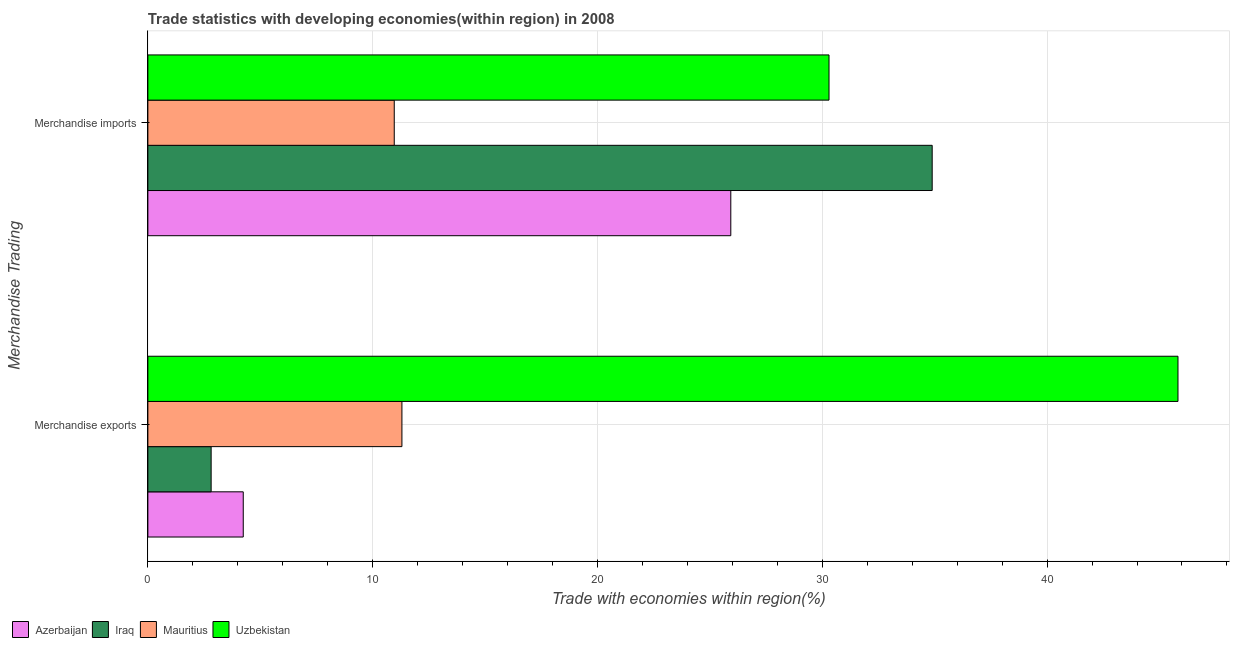How many groups of bars are there?
Give a very brief answer. 2. Are the number of bars on each tick of the Y-axis equal?
Offer a very short reply. Yes. How many bars are there on the 1st tick from the top?
Ensure brevity in your answer.  4. How many bars are there on the 2nd tick from the bottom?
Ensure brevity in your answer.  4. What is the label of the 2nd group of bars from the top?
Give a very brief answer. Merchandise exports. What is the merchandise imports in Mauritius?
Your answer should be very brief. 10.96. Across all countries, what is the maximum merchandise imports?
Your answer should be compact. 34.89. Across all countries, what is the minimum merchandise imports?
Your answer should be very brief. 10.96. In which country was the merchandise exports maximum?
Your answer should be very brief. Uzbekistan. In which country was the merchandise exports minimum?
Your answer should be compact. Iraq. What is the total merchandise imports in the graph?
Provide a short and direct response. 102.08. What is the difference between the merchandise exports in Mauritius and that in Iraq?
Offer a very short reply. 8.49. What is the difference between the merchandise exports in Uzbekistan and the merchandise imports in Iraq?
Make the answer very short. 10.93. What is the average merchandise imports per country?
Offer a terse response. 25.52. What is the difference between the merchandise imports and merchandise exports in Mauritius?
Your answer should be compact. -0.34. What is the ratio of the merchandise imports in Uzbekistan to that in Iraq?
Ensure brevity in your answer.  0.87. Is the merchandise imports in Uzbekistan less than that in Mauritius?
Provide a short and direct response. No. In how many countries, is the merchandise imports greater than the average merchandise imports taken over all countries?
Offer a terse response. 3. What does the 2nd bar from the top in Merchandise exports represents?
Provide a short and direct response. Mauritius. What does the 2nd bar from the bottom in Merchandise imports represents?
Offer a terse response. Iraq. How many countries are there in the graph?
Offer a terse response. 4. What is the title of the graph?
Make the answer very short. Trade statistics with developing economies(within region) in 2008. Does "Fiji" appear as one of the legend labels in the graph?
Keep it short and to the point. No. What is the label or title of the X-axis?
Make the answer very short. Trade with economies within region(%). What is the label or title of the Y-axis?
Offer a terse response. Merchandise Trading. What is the Trade with economies within region(%) of Azerbaijan in Merchandise exports?
Keep it short and to the point. 4.24. What is the Trade with economies within region(%) in Iraq in Merchandise exports?
Keep it short and to the point. 2.81. What is the Trade with economies within region(%) of Mauritius in Merchandise exports?
Provide a succinct answer. 11.3. What is the Trade with economies within region(%) in Uzbekistan in Merchandise exports?
Offer a terse response. 45.82. What is the Trade with economies within region(%) in Azerbaijan in Merchandise imports?
Give a very brief answer. 25.93. What is the Trade with economies within region(%) of Iraq in Merchandise imports?
Keep it short and to the point. 34.89. What is the Trade with economies within region(%) of Mauritius in Merchandise imports?
Provide a succinct answer. 10.96. What is the Trade with economies within region(%) in Uzbekistan in Merchandise imports?
Ensure brevity in your answer.  30.3. Across all Merchandise Trading, what is the maximum Trade with economies within region(%) in Azerbaijan?
Offer a very short reply. 25.93. Across all Merchandise Trading, what is the maximum Trade with economies within region(%) in Iraq?
Provide a succinct answer. 34.89. Across all Merchandise Trading, what is the maximum Trade with economies within region(%) of Mauritius?
Your response must be concise. 11.3. Across all Merchandise Trading, what is the maximum Trade with economies within region(%) of Uzbekistan?
Your response must be concise. 45.82. Across all Merchandise Trading, what is the minimum Trade with economies within region(%) of Azerbaijan?
Provide a succinct answer. 4.24. Across all Merchandise Trading, what is the minimum Trade with economies within region(%) of Iraq?
Keep it short and to the point. 2.81. Across all Merchandise Trading, what is the minimum Trade with economies within region(%) in Mauritius?
Offer a very short reply. 10.96. Across all Merchandise Trading, what is the minimum Trade with economies within region(%) of Uzbekistan?
Provide a short and direct response. 30.3. What is the total Trade with economies within region(%) of Azerbaijan in the graph?
Give a very brief answer. 30.17. What is the total Trade with economies within region(%) of Iraq in the graph?
Your response must be concise. 37.7. What is the total Trade with economies within region(%) of Mauritius in the graph?
Provide a succinct answer. 22.26. What is the total Trade with economies within region(%) of Uzbekistan in the graph?
Ensure brevity in your answer.  76.12. What is the difference between the Trade with economies within region(%) in Azerbaijan in Merchandise exports and that in Merchandise imports?
Provide a short and direct response. -21.69. What is the difference between the Trade with economies within region(%) in Iraq in Merchandise exports and that in Merchandise imports?
Give a very brief answer. -32.07. What is the difference between the Trade with economies within region(%) in Mauritius in Merchandise exports and that in Merchandise imports?
Give a very brief answer. 0.34. What is the difference between the Trade with economies within region(%) of Uzbekistan in Merchandise exports and that in Merchandise imports?
Make the answer very short. 15.52. What is the difference between the Trade with economies within region(%) of Azerbaijan in Merchandise exports and the Trade with economies within region(%) of Iraq in Merchandise imports?
Ensure brevity in your answer.  -30.65. What is the difference between the Trade with economies within region(%) in Azerbaijan in Merchandise exports and the Trade with economies within region(%) in Mauritius in Merchandise imports?
Give a very brief answer. -6.72. What is the difference between the Trade with economies within region(%) in Azerbaijan in Merchandise exports and the Trade with economies within region(%) in Uzbekistan in Merchandise imports?
Your response must be concise. -26.06. What is the difference between the Trade with economies within region(%) of Iraq in Merchandise exports and the Trade with economies within region(%) of Mauritius in Merchandise imports?
Provide a short and direct response. -8.15. What is the difference between the Trade with economies within region(%) of Iraq in Merchandise exports and the Trade with economies within region(%) of Uzbekistan in Merchandise imports?
Provide a short and direct response. -27.49. What is the difference between the Trade with economies within region(%) of Mauritius in Merchandise exports and the Trade with economies within region(%) of Uzbekistan in Merchandise imports?
Your answer should be compact. -19. What is the average Trade with economies within region(%) of Azerbaijan per Merchandise Trading?
Keep it short and to the point. 15.09. What is the average Trade with economies within region(%) of Iraq per Merchandise Trading?
Your answer should be very brief. 18.85. What is the average Trade with economies within region(%) of Mauritius per Merchandise Trading?
Keep it short and to the point. 11.13. What is the average Trade with economies within region(%) of Uzbekistan per Merchandise Trading?
Offer a very short reply. 38.06. What is the difference between the Trade with economies within region(%) in Azerbaijan and Trade with economies within region(%) in Iraq in Merchandise exports?
Your response must be concise. 1.43. What is the difference between the Trade with economies within region(%) in Azerbaijan and Trade with economies within region(%) in Mauritius in Merchandise exports?
Your answer should be compact. -7.06. What is the difference between the Trade with economies within region(%) in Azerbaijan and Trade with economies within region(%) in Uzbekistan in Merchandise exports?
Provide a short and direct response. -41.58. What is the difference between the Trade with economies within region(%) in Iraq and Trade with economies within region(%) in Mauritius in Merchandise exports?
Offer a very short reply. -8.49. What is the difference between the Trade with economies within region(%) of Iraq and Trade with economies within region(%) of Uzbekistan in Merchandise exports?
Your answer should be compact. -43.01. What is the difference between the Trade with economies within region(%) in Mauritius and Trade with economies within region(%) in Uzbekistan in Merchandise exports?
Provide a succinct answer. -34.52. What is the difference between the Trade with economies within region(%) in Azerbaijan and Trade with economies within region(%) in Iraq in Merchandise imports?
Your answer should be compact. -8.96. What is the difference between the Trade with economies within region(%) in Azerbaijan and Trade with economies within region(%) in Mauritius in Merchandise imports?
Ensure brevity in your answer.  14.97. What is the difference between the Trade with economies within region(%) in Azerbaijan and Trade with economies within region(%) in Uzbekistan in Merchandise imports?
Your answer should be very brief. -4.37. What is the difference between the Trade with economies within region(%) of Iraq and Trade with economies within region(%) of Mauritius in Merchandise imports?
Your response must be concise. 23.93. What is the difference between the Trade with economies within region(%) of Iraq and Trade with economies within region(%) of Uzbekistan in Merchandise imports?
Your answer should be compact. 4.59. What is the difference between the Trade with economies within region(%) of Mauritius and Trade with economies within region(%) of Uzbekistan in Merchandise imports?
Your answer should be compact. -19.34. What is the ratio of the Trade with economies within region(%) of Azerbaijan in Merchandise exports to that in Merchandise imports?
Make the answer very short. 0.16. What is the ratio of the Trade with economies within region(%) in Iraq in Merchandise exports to that in Merchandise imports?
Offer a very short reply. 0.08. What is the ratio of the Trade with economies within region(%) in Mauritius in Merchandise exports to that in Merchandise imports?
Offer a very short reply. 1.03. What is the ratio of the Trade with economies within region(%) in Uzbekistan in Merchandise exports to that in Merchandise imports?
Make the answer very short. 1.51. What is the difference between the highest and the second highest Trade with economies within region(%) of Azerbaijan?
Offer a very short reply. 21.69. What is the difference between the highest and the second highest Trade with economies within region(%) of Iraq?
Keep it short and to the point. 32.07. What is the difference between the highest and the second highest Trade with economies within region(%) in Mauritius?
Ensure brevity in your answer.  0.34. What is the difference between the highest and the second highest Trade with economies within region(%) in Uzbekistan?
Make the answer very short. 15.52. What is the difference between the highest and the lowest Trade with economies within region(%) of Azerbaijan?
Your response must be concise. 21.69. What is the difference between the highest and the lowest Trade with economies within region(%) of Iraq?
Your answer should be compact. 32.07. What is the difference between the highest and the lowest Trade with economies within region(%) in Mauritius?
Ensure brevity in your answer.  0.34. What is the difference between the highest and the lowest Trade with economies within region(%) of Uzbekistan?
Your response must be concise. 15.52. 